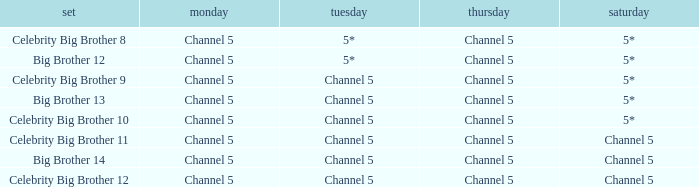Which Tuesday does big brother 12 air? 5*. 